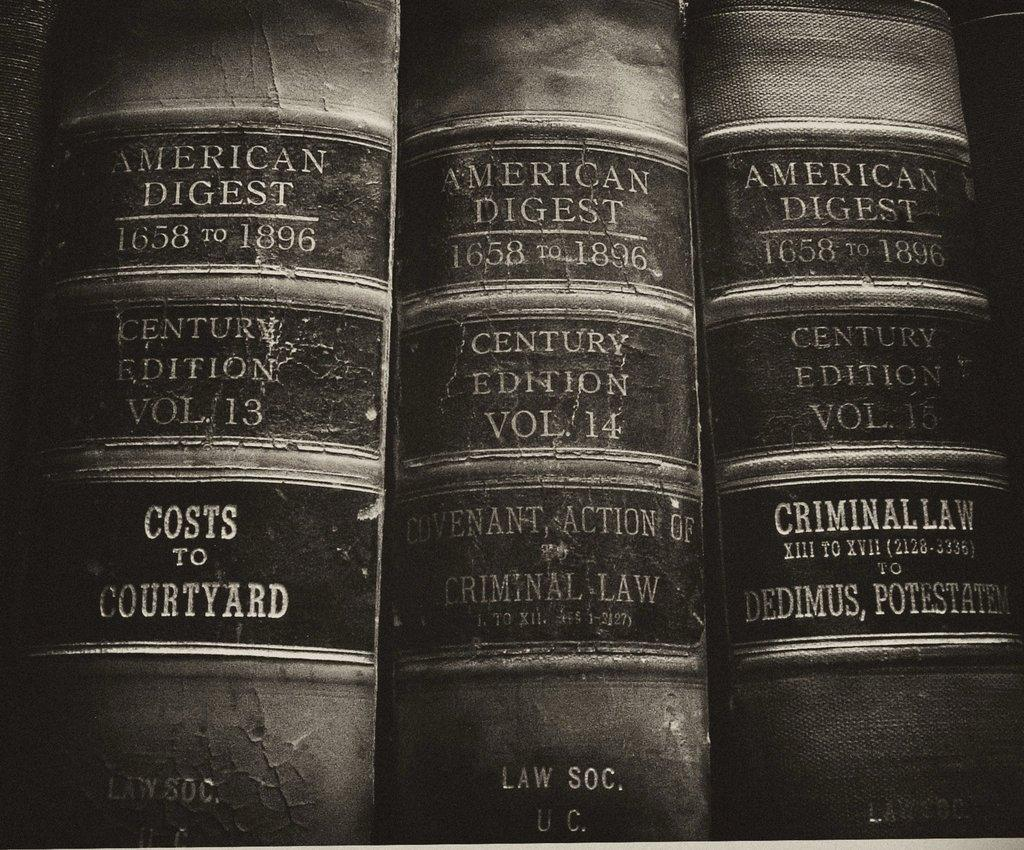<image>
Give a short and clear explanation of the subsequent image. three american digest books law books vol 13 14 and 15 